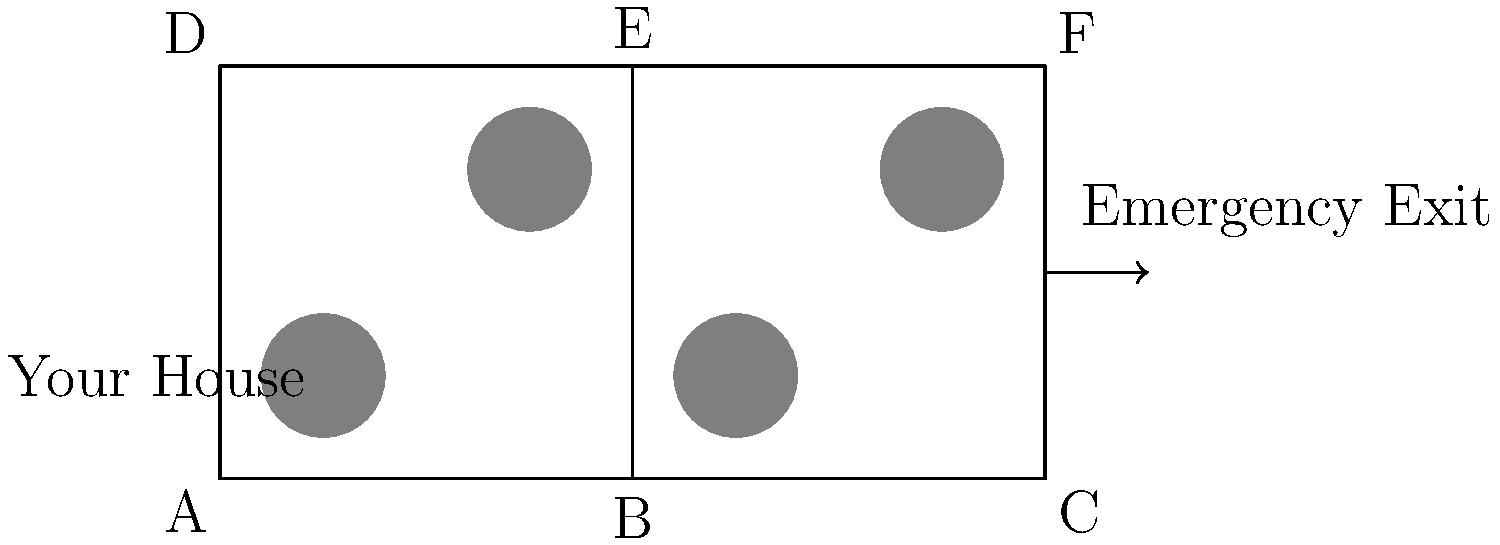As a resident of Mt. Olive, TN, concerned about safety and emergency preparedness, you need to identify the most efficient evacuation route from your house to the emergency exit. Given the neighborhood map, which sequence of intersections represents the shortest path from your house to the emergency exit? To find the most efficient evacuation route, we need to analyze the map and determine the shortest path from the house to the emergency exit. Let's break it down step-by-step:

1. Locate your house: Your house is near intersection A.
2. Locate the emergency exit: The exit is on the right side of the map, near intersection C and F.
3. Identify possible routes:
   - Route 1: A → B → C
   - Route 2: A → B → E → F
   - Route 3: A → D → E → F

4. Analyze the routes:
   - Route 1 is a straight line from A to C, passing through B.
   - Route 2 and Route 3 both require two turns and cover more distance.

5. Compare distances:
   - Route 1 covers approximately 4 units (2 units from A to B, and 2 units from B to C).
   - Routes 2 and 3 cover more than 4 units due to the additional turn.

6. Consider traffic flow:
   - Route 1 follows the main road, which is likely designed for efficient traffic flow.

Based on this analysis, Route 1 (A → B → C) is the shortest and most direct path, making it the most efficient evacuation route from your house to the emergency exit.
Answer: A → B → C 